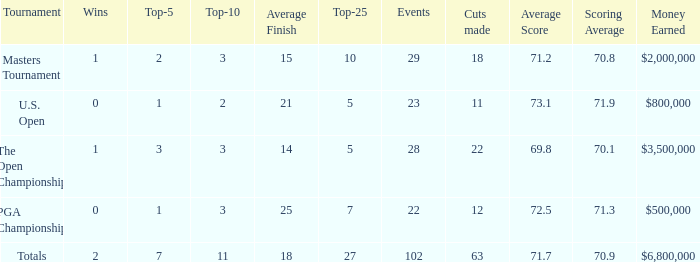How many vuts made for a player with 2 wins and under 7 top 5s? None. Could you help me parse every detail presented in this table? {'header': ['Tournament', 'Wins', 'Top-5', 'Top-10', 'Average Finish', 'Top-25', 'Events', 'Cuts made', 'Average Score', 'Scoring Average', 'Money Earned'], 'rows': [['Masters Tournament', '1', '2', '3', '15', '10', '29', '18', '71.2', '70.8', '$2,000,000'], ['U.S. Open', '0', '1', '2', '21', '5', '23', '11', '73.1', '71.9', '$800,000'], ['The Open Championship', '1', '3', '3', '14', '5', '28', '22', '69.8', '70.1', '$3,500,000'], ['PGA Championship', '0', '1', '3', '25', '7', '22', '12', '72.5', '71.3', '$500,000'], ['Totals', '2', '7', '11', '18', '27', '102', '63', '71.7', '70.9', '$6,800,000']]} 